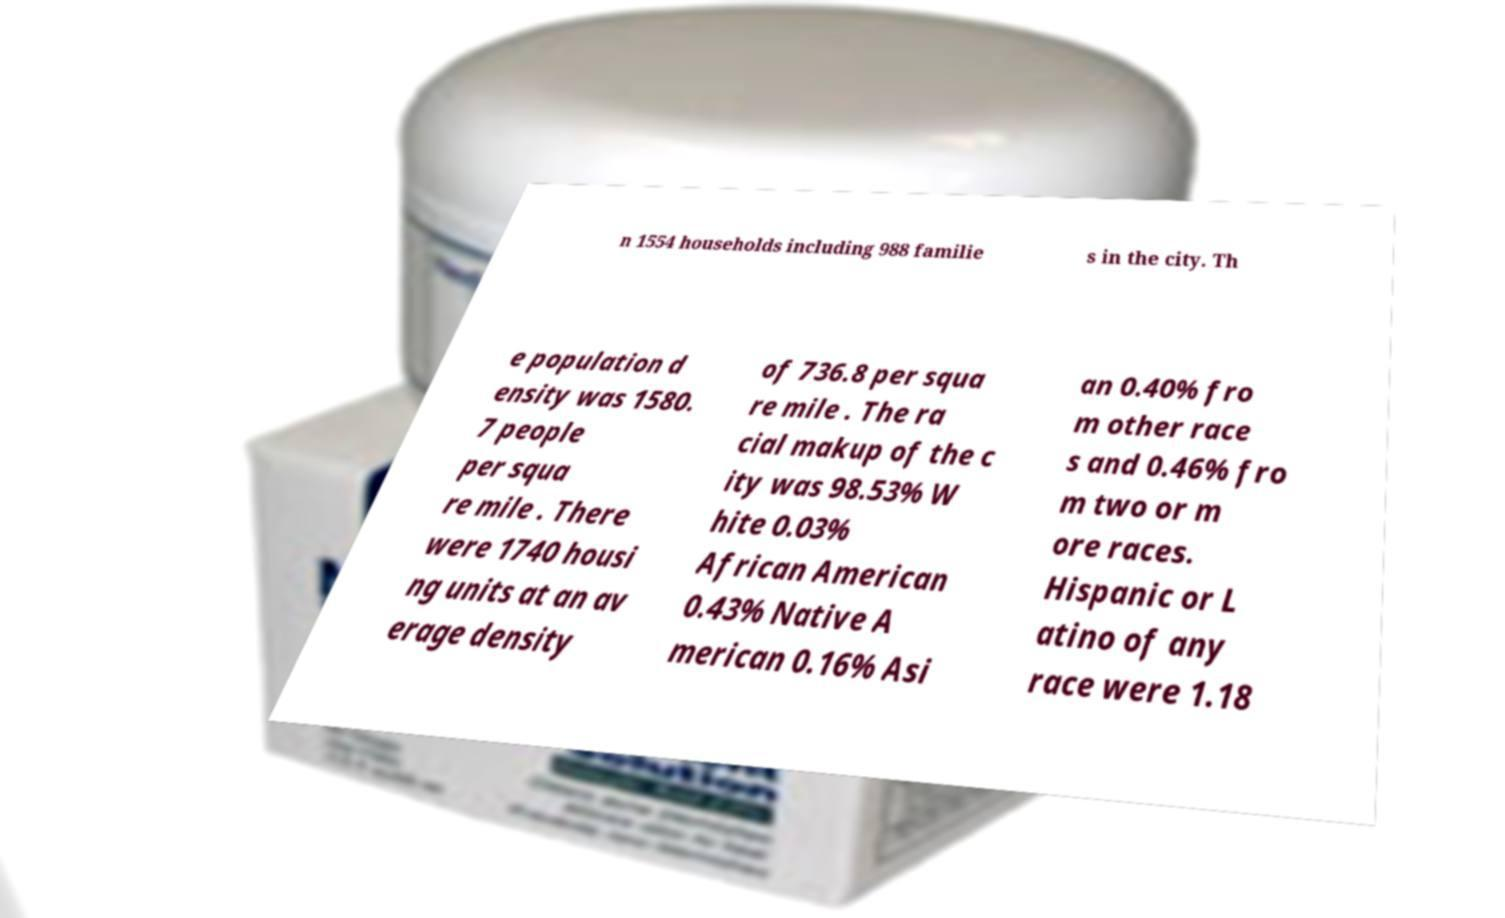I need the written content from this picture converted into text. Can you do that? n 1554 households including 988 familie s in the city. Th e population d ensity was 1580. 7 people per squa re mile . There were 1740 housi ng units at an av erage density of 736.8 per squa re mile . The ra cial makup of the c ity was 98.53% W hite 0.03% African American 0.43% Native A merican 0.16% Asi an 0.40% fro m other race s and 0.46% fro m two or m ore races. Hispanic or L atino of any race were 1.18 